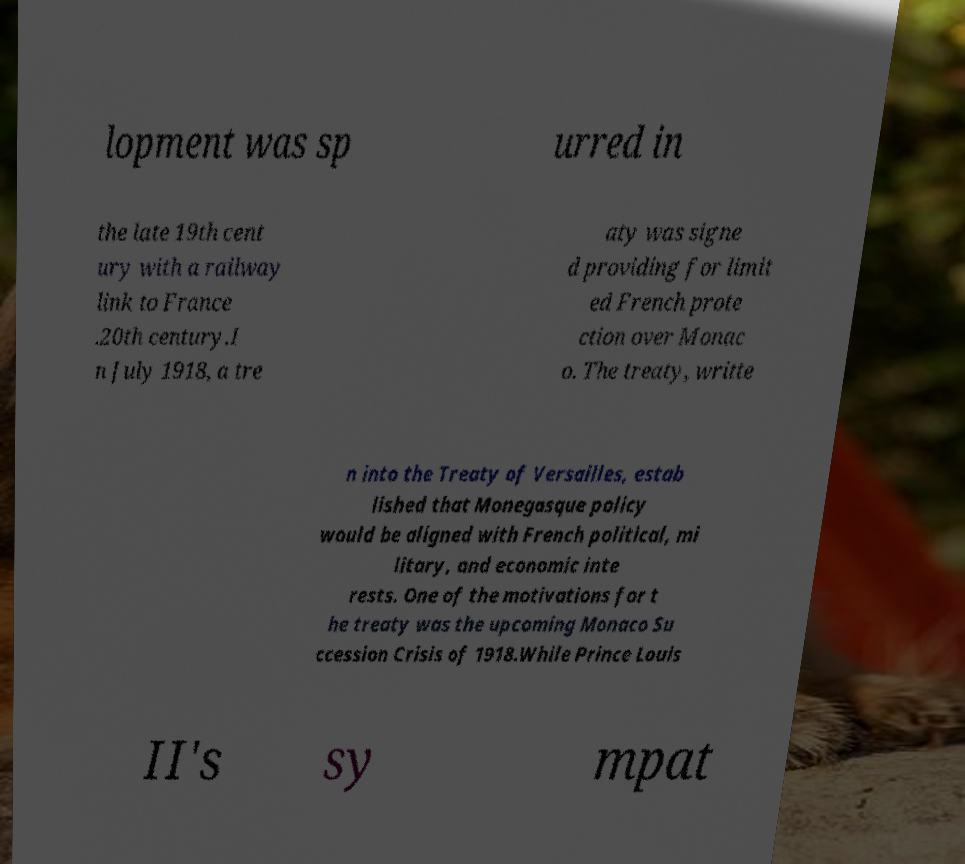Can you read and provide the text displayed in the image?This photo seems to have some interesting text. Can you extract and type it out for me? lopment was sp urred in the late 19th cent ury with a railway link to France .20th century.I n July 1918, a tre aty was signe d providing for limit ed French prote ction over Monac o. The treaty, writte n into the Treaty of Versailles, estab lished that Monegasque policy would be aligned with French political, mi litary, and economic inte rests. One of the motivations for t he treaty was the upcoming Monaco Su ccession Crisis of 1918.While Prince Louis II's sy mpat 